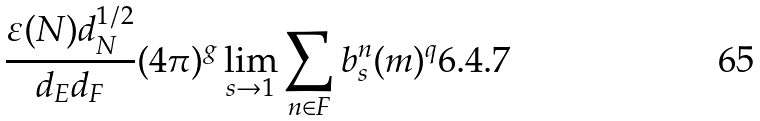Convert formula to latex. <formula><loc_0><loc_0><loc_500><loc_500>\frac { \varepsilon ( N ) d _ { N } ^ { 1 / 2 } } { d _ { E } d _ { F } } ( 4 \pi ) ^ { g } \lim _ { s \to 1 } \sum _ { n \in F } b ^ { n } _ { s } ( m ) ^ { q } { 6 . 4 . 7 }</formula> 